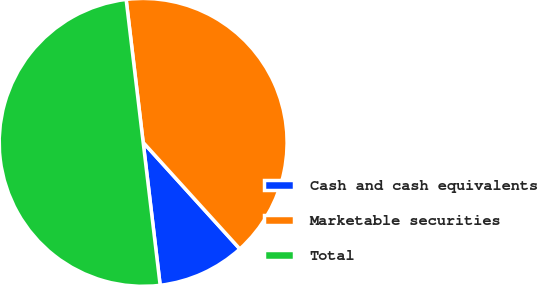Convert chart to OTSL. <chart><loc_0><loc_0><loc_500><loc_500><pie_chart><fcel>Cash and cash equivalents<fcel>Marketable securities<fcel>Total<nl><fcel>9.84%<fcel>40.16%<fcel>50.0%<nl></chart> 